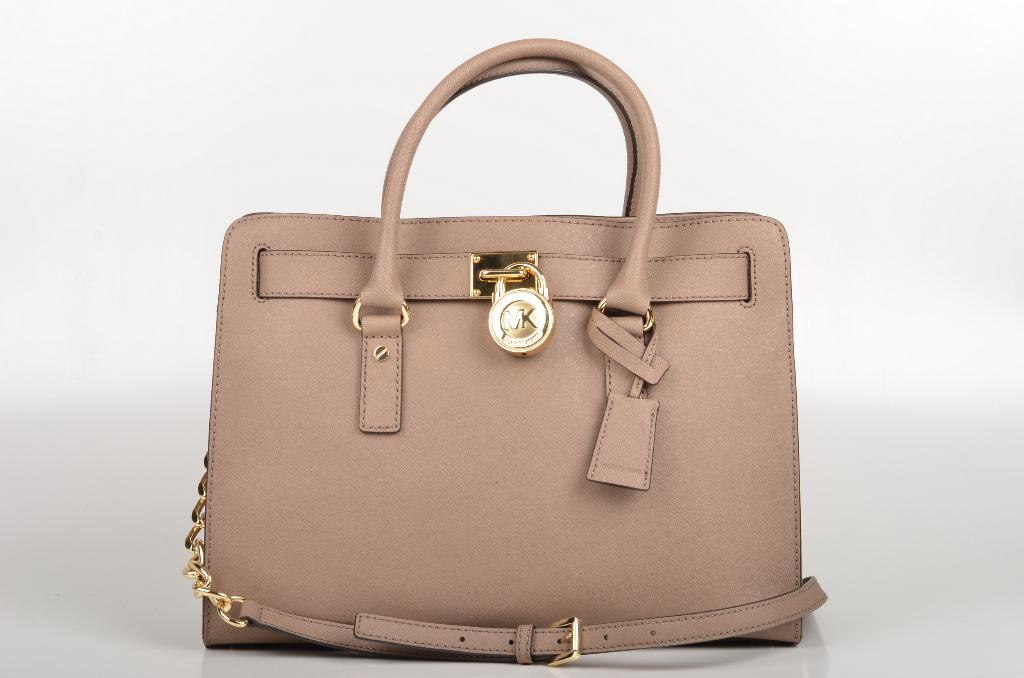What type of polish is being applied to the beetle on the boat in the image? There is no image provided, and therefore no boat, beetle, or polish can be observed. 